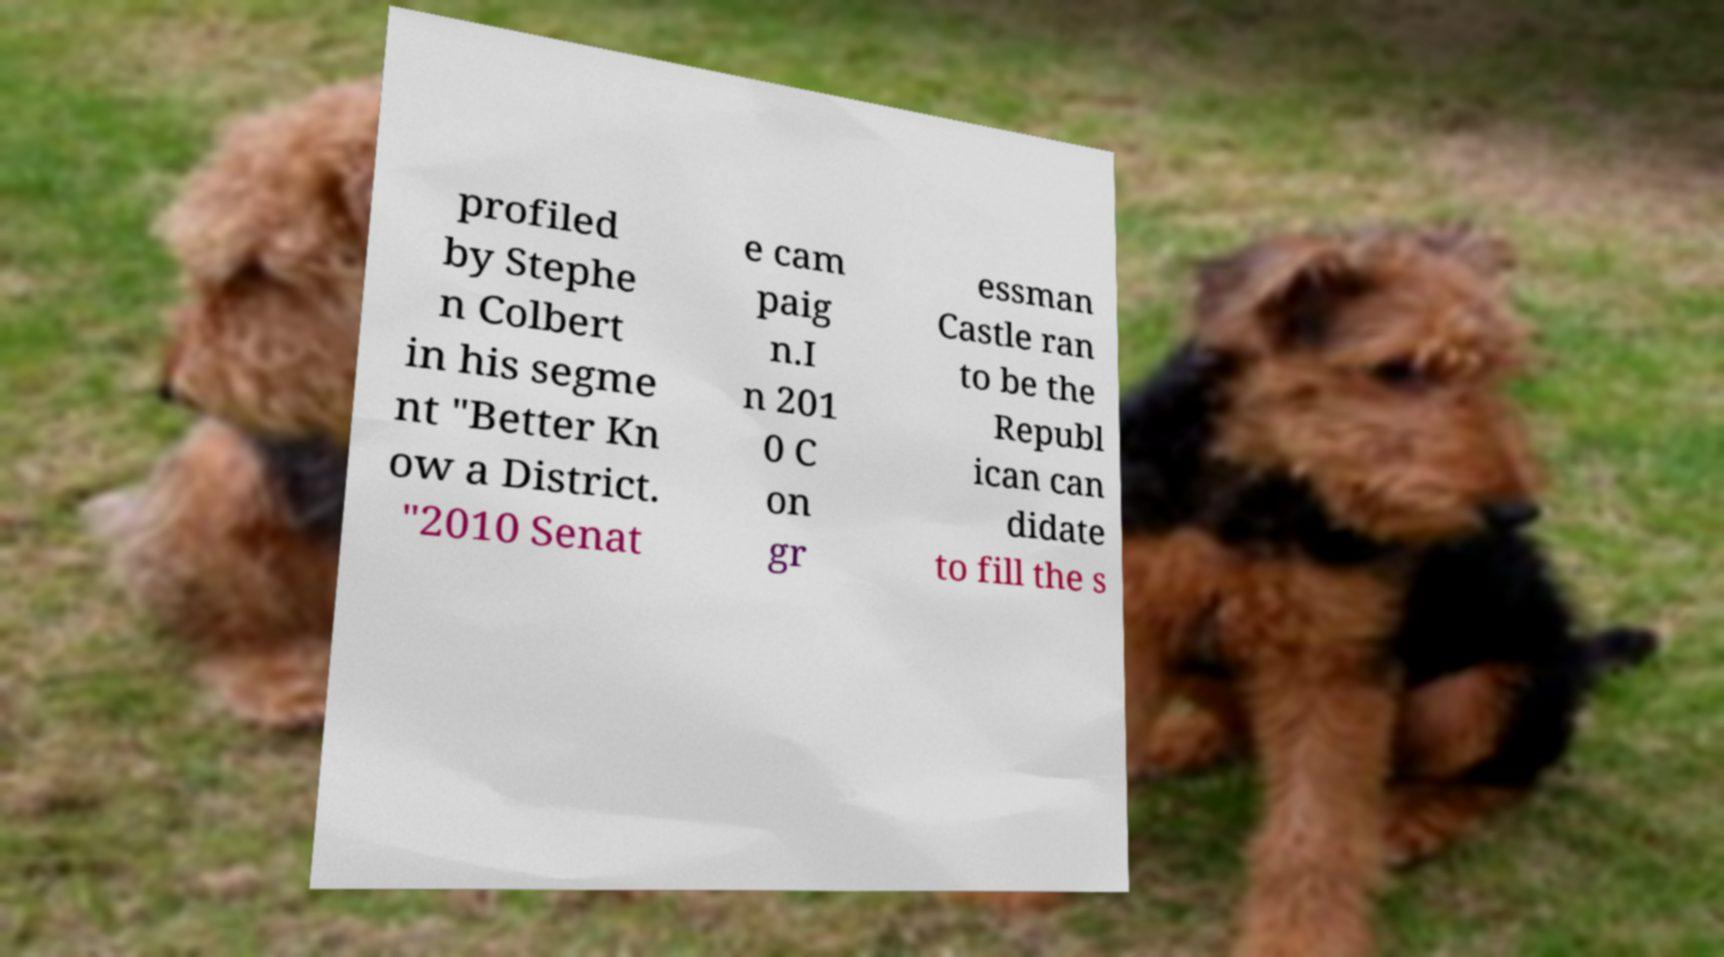There's text embedded in this image that I need extracted. Can you transcribe it verbatim? profiled by Stephe n Colbert in his segme nt "Better Kn ow a District. "2010 Senat e cam paig n.I n 201 0 C on gr essman Castle ran to be the Republ ican can didate to fill the s 